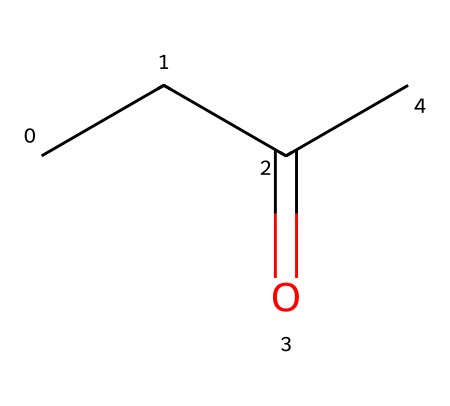What is the molecular formula of 2-butanone? To find the molecular formula, count the number of carbon (C), hydrogen (H), and oxygen (O) atoms in the structure. The structure has 4 carbon atoms, 8 hydrogen atoms, and 1 oxygen atom, which leads to the formula C4H8O.
Answer: C4H8O How many carbon atoms are present in 2-butanone? By examining the SMILES representation, we can see that there are four carbon atoms indicated by the "C" symbols.
Answer: 4 What type of functional group is present in 2-butanone? The presence of the carbonyl group (C=O) in the structure indicates that it is a ketone, specifically due to the arrangement of carbon atoms surrounding the carbonyl.
Answer: ketone Which is the functional group that distinguishes ketones from other organic compounds? The defining feature of ketones is the carbonyl group (C=O) connected to two carbon atoms, which can be identified by looking at the arrangement of the atoms in the structure.
Answer: carbonyl group How many double bonds are present in the 2-butanone structure? Evaluating the structure reveals that there is only one double bond, which is the carbonyl group (C=O), so there are no additional double bonds in the structure.
Answer: 1 What is the branched structure related to the 2-butanone? The structure indicates that there are no branches since it consists of a linear sequence of carbon atoms leading to the carbonyl group, showing that it is not branched.
Answer: none What is the total number of hydrogen atoms on the carbonyl carbon in 2-butanone? The carbon atom in the carbonyl group (C=O) is bonded to one hydrogen atom, as the carbonyl carbon forms a double bond with oxygen and is then singly bonded to a remaining carbon.
Answer: 1 